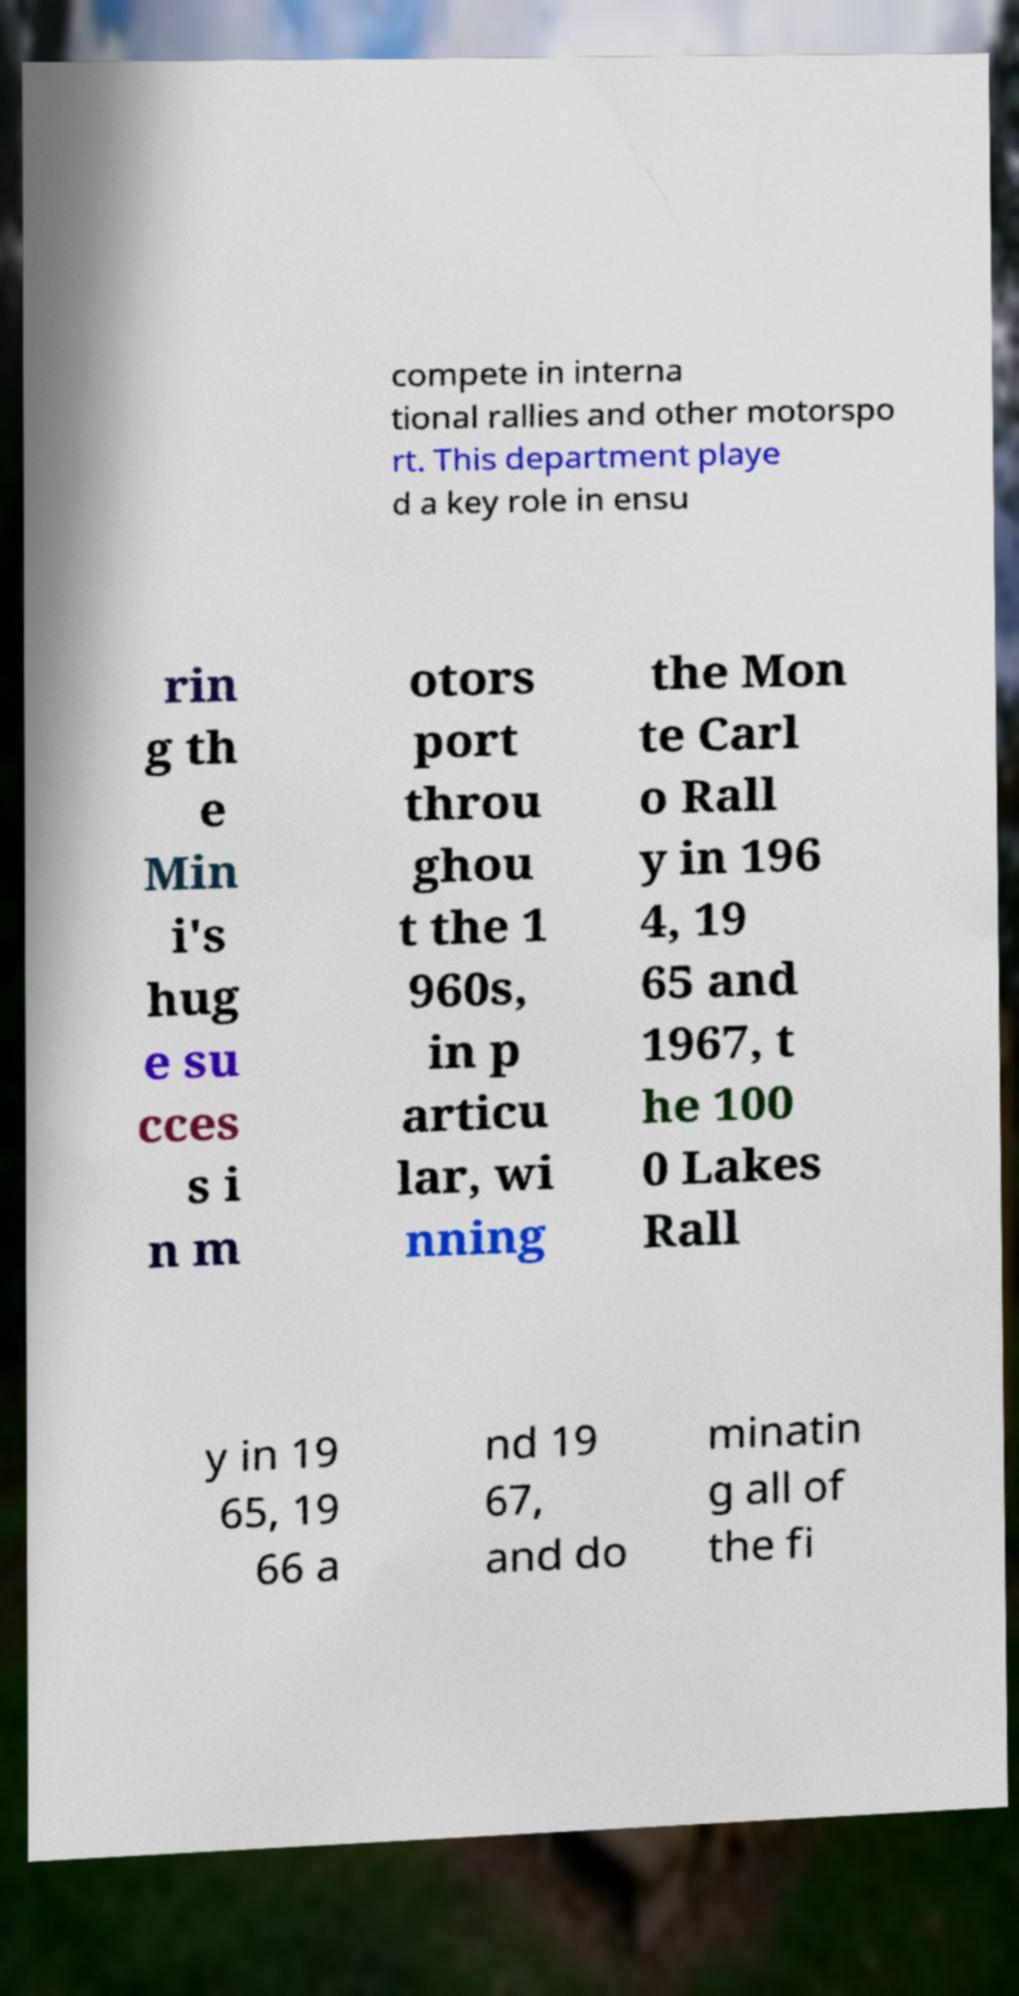For documentation purposes, I need the text within this image transcribed. Could you provide that? compete in interna tional rallies and other motorspo rt. This department playe d a key role in ensu rin g th e Min i's hug e su cces s i n m otors port throu ghou t the 1 960s, in p articu lar, wi nning the Mon te Carl o Rall y in 196 4, 19 65 and 1967, t he 100 0 Lakes Rall y in 19 65, 19 66 a nd 19 67, and do minatin g all of the fi 